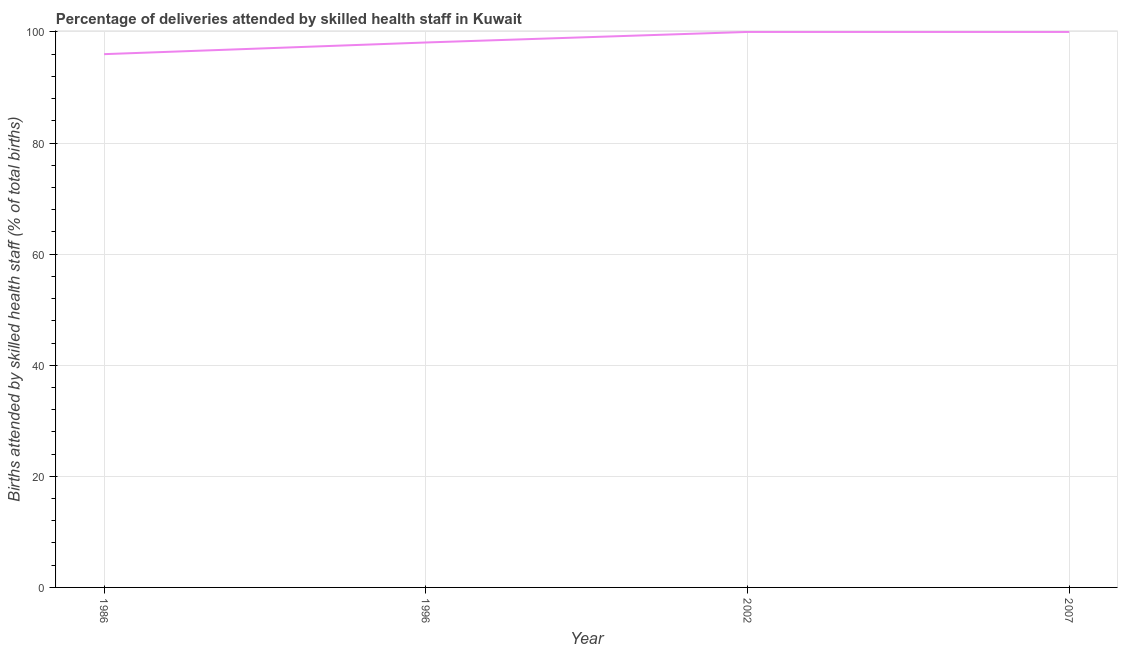What is the number of births attended by skilled health staff in 1996?
Make the answer very short. 98.1. Across all years, what is the minimum number of births attended by skilled health staff?
Make the answer very short. 96. In which year was the number of births attended by skilled health staff maximum?
Give a very brief answer. 2002. What is the sum of the number of births attended by skilled health staff?
Offer a terse response. 394.1. What is the difference between the number of births attended by skilled health staff in 1996 and 2007?
Provide a succinct answer. -1.9. What is the average number of births attended by skilled health staff per year?
Your response must be concise. 98.53. What is the median number of births attended by skilled health staff?
Provide a short and direct response. 99.05. In how many years, is the number of births attended by skilled health staff greater than 60 %?
Your answer should be compact. 4. What is the difference between the highest and the second highest number of births attended by skilled health staff?
Ensure brevity in your answer.  0. Is the sum of the number of births attended by skilled health staff in 1986 and 2007 greater than the maximum number of births attended by skilled health staff across all years?
Your response must be concise. Yes. What is the difference between the highest and the lowest number of births attended by skilled health staff?
Provide a succinct answer. 4. Does the number of births attended by skilled health staff monotonically increase over the years?
Your response must be concise. No. Does the graph contain any zero values?
Keep it short and to the point. No. What is the title of the graph?
Your response must be concise. Percentage of deliveries attended by skilled health staff in Kuwait. What is the label or title of the X-axis?
Your answer should be compact. Year. What is the label or title of the Y-axis?
Make the answer very short. Births attended by skilled health staff (% of total births). What is the Births attended by skilled health staff (% of total births) in 1986?
Your answer should be compact. 96. What is the Births attended by skilled health staff (% of total births) in 1996?
Ensure brevity in your answer.  98.1. What is the Births attended by skilled health staff (% of total births) in 2002?
Offer a very short reply. 100. What is the difference between the Births attended by skilled health staff (% of total births) in 1986 and 1996?
Your answer should be very brief. -2.1. What is the difference between the Births attended by skilled health staff (% of total births) in 1986 and 2007?
Your answer should be very brief. -4. What is the difference between the Births attended by skilled health staff (% of total births) in 1996 and 2002?
Make the answer very short. -1.9. What is the ratio of the Births attended by skilled health staff (% of total births) in 1986 to that in 1996?
Keep it short and to the point. 0.98. What is the ratio of the Births attended by skilled health staff (% of total births) in 1986 to that in 2002?
Your response must be concise. 0.96. What is the ratio of the Births attended by skilled health staff (% of total births) in 1986 to that in 2007?
Your answer should be very brief. 0.96. What is the ratio of the Births attended by skilled health staff (% of total births) in 1996 to that in 2007?
Offer a very short reply. 0.98. 